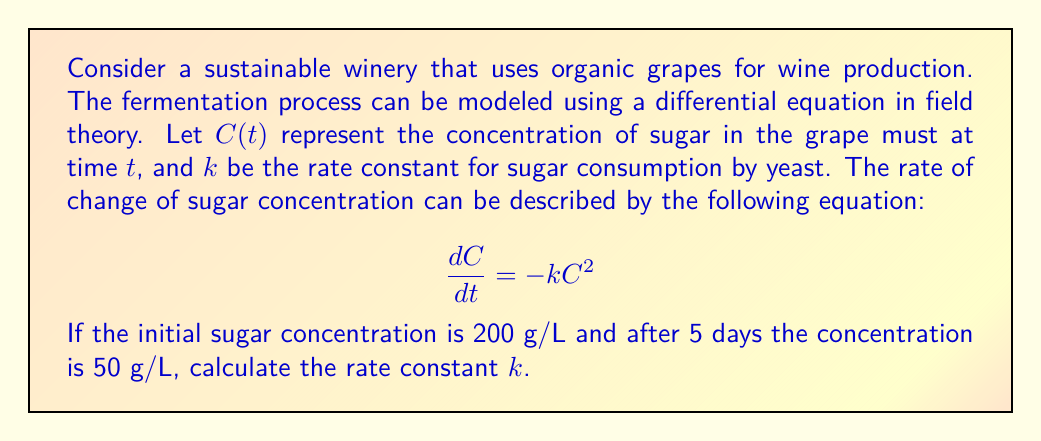Could you help me with this problem? To solve this problem, we'll follow these steps:

1. Identify the given information:
   - Initial sugar concentration $C_0 = 200$ g/L
   - Final sugar concentration $C_f = 50$ g/L
   - Time elapsed $t = 5$ days

2. Solve the differential equation:
   $$\frac{dC}{dt} = -kC^2$$
   
   Separating variables:
   $$\frac{dC}{C^2} = -k dt$$
   
   Integrating both sides:
   $$\int_{C_0}^{C_f} \frac{dC}{C^2} = -k \int_0^t dt$$
   
   Evaluating the integrals:
   $$\left[-\frac{1}{C}\right]_{C_0}^{C_f} = -kt$$
   
   $$\left(-\frac{1}{C_f} + \frac{1}{C_0}\right) = kt$$

3. Substitute the known values:
   $$\left(-\frac{1}{50} + \frac{1}{200}\right) = k \cdot 5$$
   
   $$\left(-0.02 + 0.005\right) = 5k$$
   
   $$-0.015 = 5k$$

4. Solve for $k$:
   $$k = \frac{-0.015}{5} = -0.003$$

5. Express $k$ in positive form (as it represents a rate constant):
   $$k = 0.003$$ L/(g·day)
Answer: $k = 0.003$ L/(g·day) 